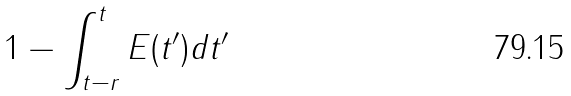Convert formula to latex. <formula><loc_0><loc_0><loc_500><loc_500>1 - \int _ { t - r } ^ { t } E ( t ^ { \prime } ) d t ^ { \prime }</formula> 